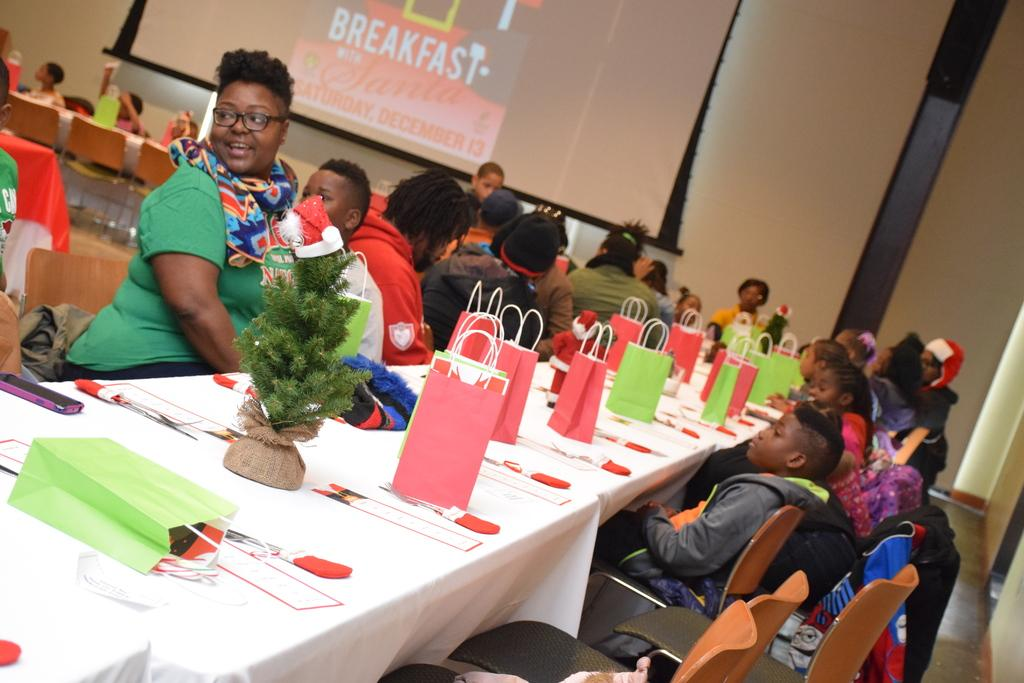What are the people in the image doing? There is a group of people sitting on chairs in the image. What is on the table in the image? There is a bag, a flower pot, and a mobile on the table in the image. Can you describe the screen in the background? There is a screen on the wall in the background of the image. What is the texture of the vein in the image? There is no vein present in the image. 